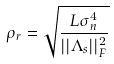<formula> <loc_0><loc_0><loc_500><loc_500>\rho _ { r } = \sqrt { \frac { L \sigma _ { n } ^ { 4 } } { | | { \Lambda } _ { s } | | _ { F } ^ { 2 } } }</formula> 